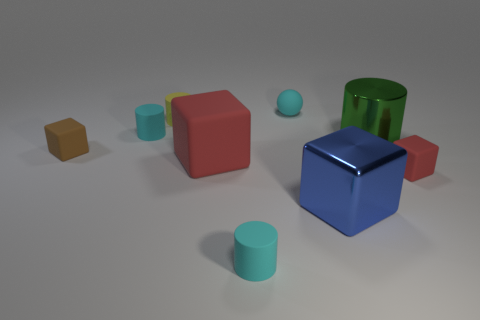Subtract 1 cylinders. How many cylinders are left? 3 Subtract all spheres. How many objects are left? 8 Subtract 0 gray cylinders. How many objects are left? 9 Subtract all cubes. Subtract all large shiny cubes. How many objects are left? 4 Add 3 shiny objects. How many shiny objects are left? 5 Add 2 big shiny balls. How many big shiny balls exist? 2 